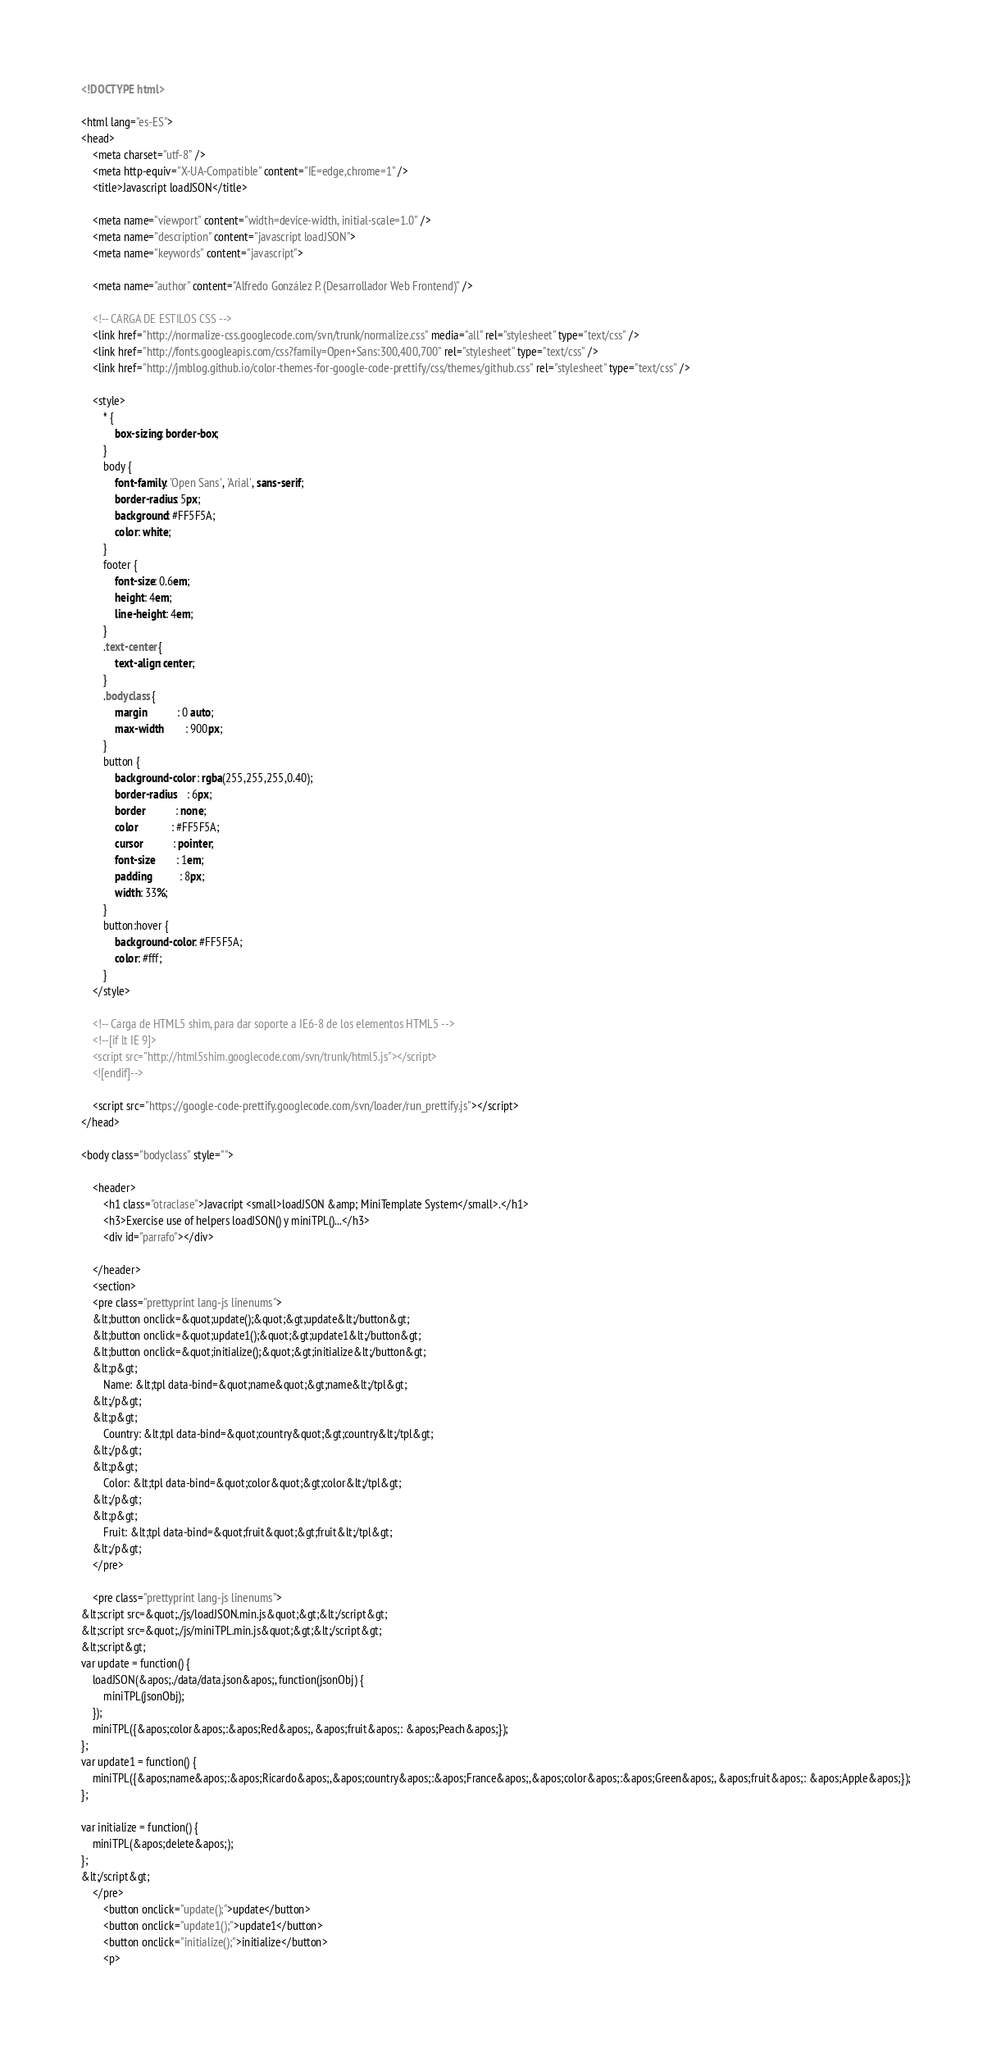<code> <loc_0><loc_0><loc_500><loc_500><_HTML_><!DOCTYPE html>

<html lang="es-ES">
<head>
	<meta charset="utf-8" />
	<meta http-equiv="X-UA-Compatible" content="IE=edge,chrome=1" />
	<title>Javascript loadJSON</title>

	<meta name="viewport" content="width=device-width, initial-scale=1.0" />
	<meta name="description" content="javascript loadJSON">
	<meta name="keywords" content="javascript">
	
	<meta name="author" content="Alfredo González P. (Desarrollador Web Frontend)" />

	<!-- CARGA DE ESTILOS CSS -->
	<link href="http://normalize-css.googlecode.com/svn/trunk/normalize.css" media="all" rel="stylesheet" type="text/css" />
	<link href="http://fonts.googleapis.com/css?family=Open+Sans:300,400,700" rel="stylesheet" type="text/css" />
	<link href="http://jmblog.github.io/color-themes-for-google-code-prettify/css/themes/github.css" rel="stylesheet" type="text/css" />

	<style>
		* {
			box-sizing: border-box;
		}
		body {
			font-family: 'Open Sans', 'Arial', sans-serif;
			border-radius: 5px;
			background: #FF5F5A;
			color: white;
		}
		footer {
			font-size: 0.6em;
			height: 4em;
			line-height: 4em;
		}
		.text-center {
			text-align: center;
		}
		.bodyclass {
			margin           : 0 auto;
			max-width        : 900px;
		}
		button {
			background-color : rgba(255,255,255,0.40);
			border-radius    : 6px;
			border           : none;
			color            : #FF5F5A;
			cursor           : pointer;
			font-size        : 1em;
			padding          : 8px;
			width: 33%;
		}
		button:hover {
			background-color: #FF5F5A;
			color: #fff;
		}
	</style>

	<!-- Carga de HTML5 shim, para dar soporte a IE6-8 de los elementos HTML5 -->
	<!--[if lt IE 9]>
	<script src="http://html5shim.googlecode.com/svn/trunk/html5.js"></script>
	<![endif]-->

	<script src="https://google-code-prettify.googlecode.com/svn/loader/run_prettify.js"></script>
</head>

<body class="bodyclass" style="">

	<header>
		<h1 class="otraclase">Javacript <small>loadJSON &amp; MiniTemplate System</small>.</h1>
		<h3>Exercise use of helpers loadJSON() y miniTPL()...</h3>
		<div id="parrafo"></div>

	</header>
	<section>
	<pre class="prettyprint lang-js linenums">
	&lt;button onclick=&quot;update();&quot;&gt;update&lt;/button&gt;
	&lt;button onclick=&quot;update1();&quot;&gt;update1&lt;/button&gt;
	&lt;button onclick=&quot;initialize();&quot;&gt;initialize&lt;/button&gt;
	&lt;p&gt;
		Name: &lt;tpl data-bind=&quot;name&quot;&gt;name&lt;/tpl&gt;
	&lt;/p&gt;
	&lt;p&gt;
		Country: &lt;tpl data-bind=&quot;country&quot;&gt;country&lt;/tpl&gt;
	&lt;/p&gt;
	&lt;p&gt;
		Color: &lt;tpl data-bind=&quot;color&quot;&gt;color&lt;/tpl&gt;
	&lt;/p&gt;
	&lt;p&gt;
		Fruit: &lt;tpl data-bind=&quot;fruit&quot;&gt;fruit&lt;/tpl&gt;
	&lt;/p&gt;
	</pre>

	<pre class="prettyprint lang-js linenums">
&lt;script src=&quot;./js/loadJSON.min.js&quot;&gt;&lt;/script&gt;
&lt;script src=&quot;./js/miniTPL.min.js&quot;&gt;&lt;/script&gt;
&lt;script&gt;
var update = function() {
	loadJSON(&apos;./data/data.json&apos;, function(jsonObj) {
		miniTPL(jsonObj);
	});
	miniTPL({&apos;color&apos;:&apos;Red&apos;, &apos;fruit&apos;: &apos;Peach&apos;});
};
var update1 = function() {
	miniTPL({&apos;name&apos;:&apos;Ricardo&apos;,&apos;country&apos;:&apos;France&apos;,&apos;color&apos;:&apos;Green&apos;, &apos;fruit&apos;: &apos;Apple&apos;});
};

var initialize = function() {
	miniTPL(&apos;delete&apos;);
};
&lt;/script&gt;
	</pre>
		<button onclick="update();">update</button>
		<button onclick="update1();">update1</button>
		<button onclick="initialize();">initialize</button>
		<p></code> 